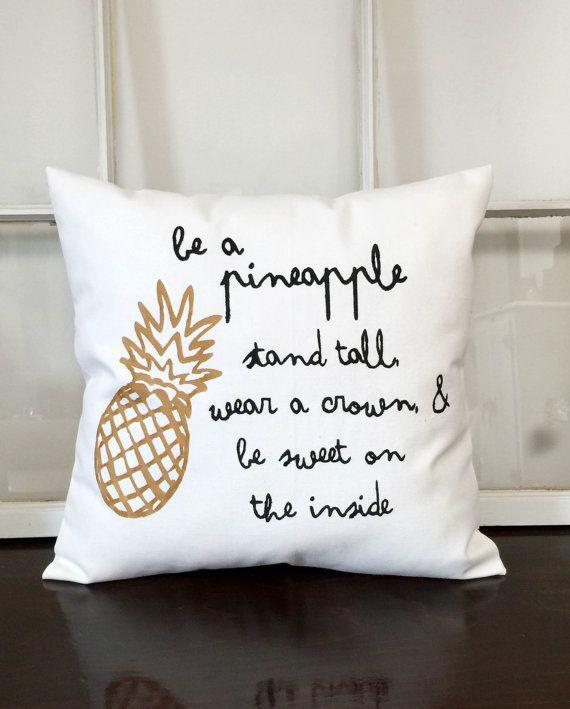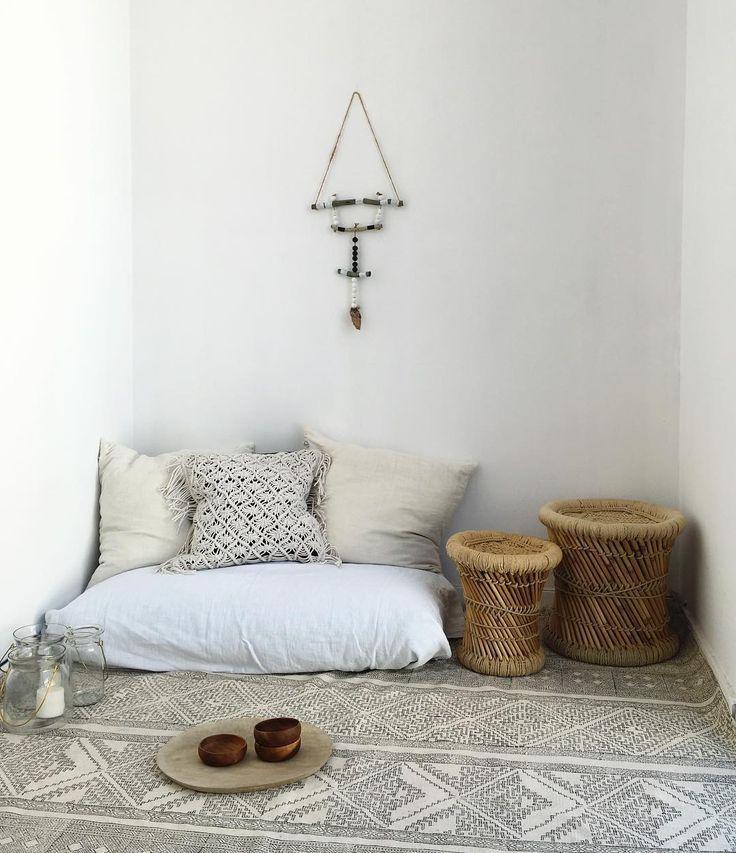The first image is the image on the left, the second image is the image on the right. Examine the images to the left and right. Is the description "The left image includes a text-printed square pillow on a square wood stand, and the right image includes a pillow with a mammal depicted on it." accurate? Answer yes or no. No. The first image is the image on the left, the second image is the image on the right. Assess this claim about the two images: "All of the pillows are printed with a novelty design.". Correct or not? Answer yes or no. No. 